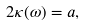Convert formula to latex. <formula><loc_0><loc_0><loc_500><loc_500>2 \kappa ( \omega ) = a ,</formula> 